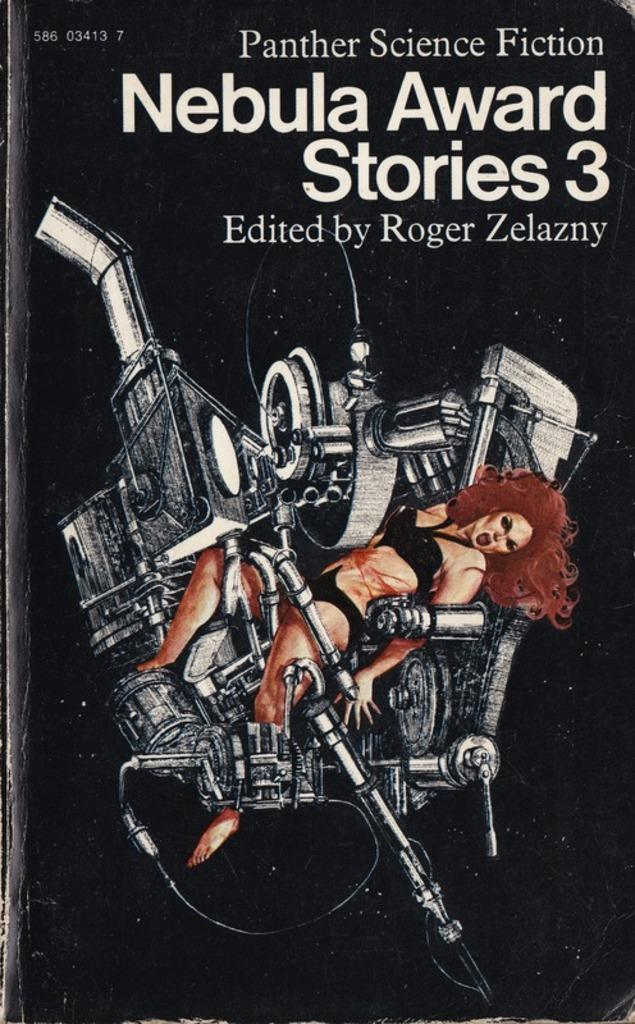<image>
Write a terse but informative summary of the picture. The cover of Nebula Award Stories 3 by Roger Zelazny. 